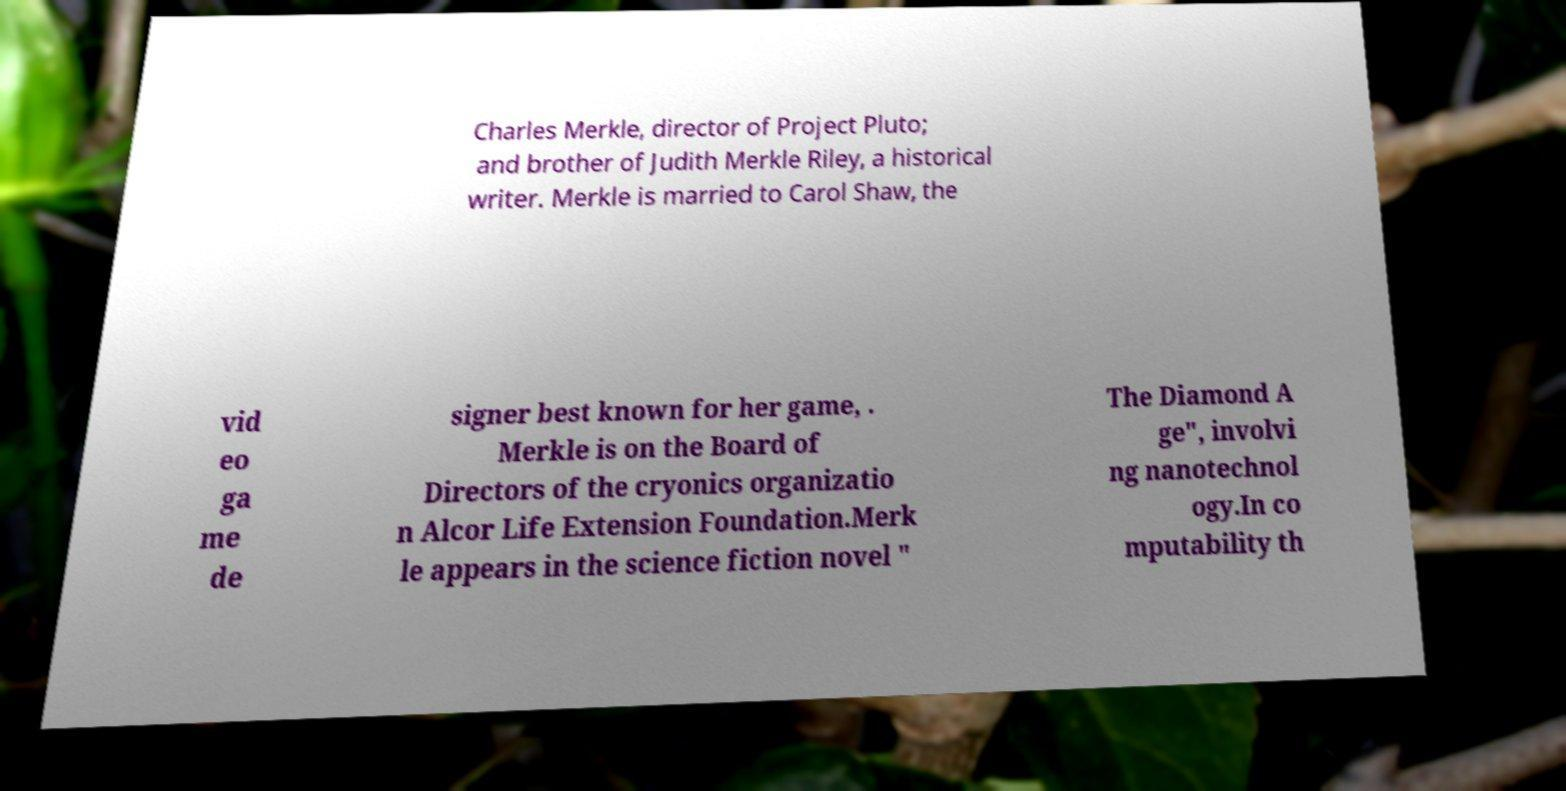Please identify and transcribe the text found in this image. Charles Merkle, director of Project Pluto; and brother of Judith Merkle Riley, a historical writer. Merkle is married to Carol Shaw, the vid eo ga me de signer best known for her game, . Merkle is on the Board of Directors of the cryonics organizatio n Alcor Life Extension Foundation.Merk le appears in the science fiction novel " The Diamond A ge", involvi ng nanotechnol ogy.In co mputability th 